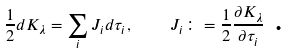<formula> <loc_0><loc_0><loc_500><loc_500>\frac { 1 } { 2 } d K _ { \lambda } = \sum _ { i } J _ { i } d \tau _ { i } , \quad J _ { i } \colon = \frac { 1 } { 2 } \frac { \partial K _ { \lambda } } { \partial \tau _ { i } } \text { .}</formula> 